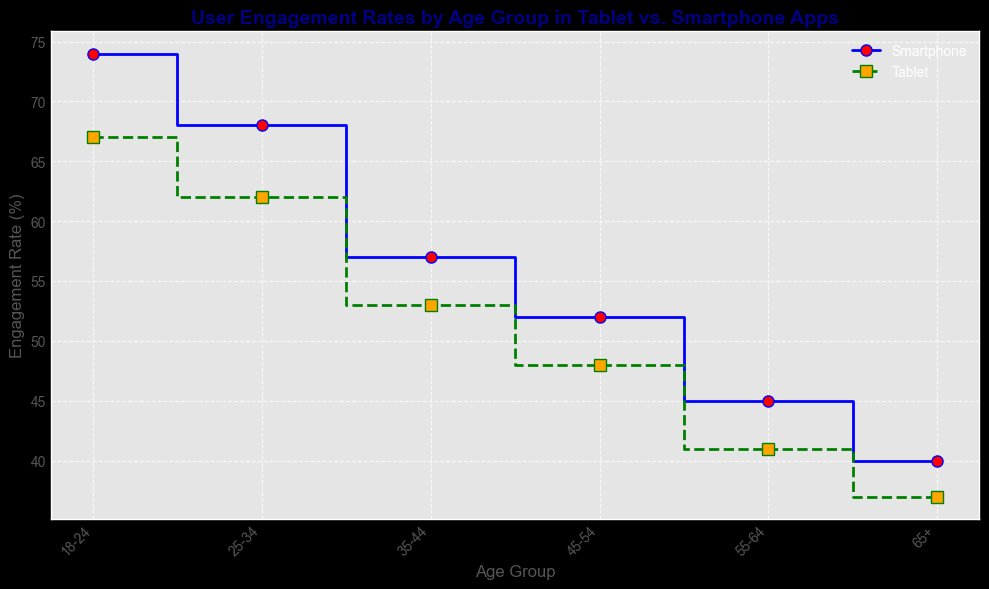What is the engagement rate for the 25-34 age group using smartphones? The figure shows the engagement rates for different age groups and devices. For the 25-34 age group under the "Smartphone" label, the engagement rate is displayed as a point on the step line.
Answer: 68 How much higher is the engagement rate for the 18-24 age group on smartphones compared to tablets? The engagement rate for the 18-24 age group is 74% for smartphones and 67% for tablets. Subtracting the tablet rate from the smartphone rate gives the difference: 74 - 67 = 7.
Answer: 7% Which age group has the least engagement rate on tablets? By inspecting the green step line representing tablets, the lowest point on the plot is for the 65+ age group, which has an engagement rate of 37%.
Answer: 65+ Between which age groups does the smartphone engagement rate drop the most? Looking at the blue step line between consecutive age groups, the largest drop is between the 25-34 and 35-44 age groups, from 68% to 57%. The difference is 68 - 57 = 11.
Answer: 25-34 to 35-44 Are there any age groups where smartphone and tablet engagement rates are equal? Inspecting the blue and green step lines across all age groups, there is no point where the engagement rates for smartphones and tablets are the same.
Answer: No What is the average engagement rate for the 45-54 age group across both devices? For the 45-54 age group, the engagement rates are 52% for smartphones and 48% for tablets. The average is calculated by adding the rates and dividing by 2: (52 + 48) / 2 = 100 / 2 = 50.
Answer: 50% Does the general trend show higher engagement on tablets or smartphones for younger age groups? Analyzing the plot, both step lines show higher engagement rates for younger age groups. Specifically, for the 18-24 and 25-34 age groups, smartphones always have higher engagement rates than tablets.
Answer: Smartphones For the age group 55-64, do tablets have a higher engagement rate compared to the 65+ age group using smartphones? The engagement rate for the 55-64 age group on tablets is 41%, and the engagement rate for the 65+ age group on smartphones is 40%. Comparing these, 41 is greater than 40.
Answer: Yes What is the percentage decrease in engagement from the 35-44 to 45-54 age group for tablets? The engagement rate for the 35-44 age group on tablets is 53%, and for the 45-54 age group, it is 48%. The percentage decrease is calculated as ((53 - 48) / 53) * 100 = (5 / 53) * 100 ≈ 9.43%.
Answer: ≈ 9.43% 